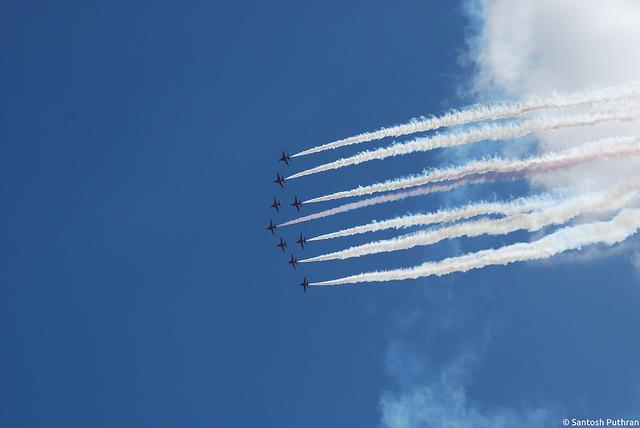What is the white trail behind the plane called? Please explain your reasoning. contrail. The lines are in the sky 